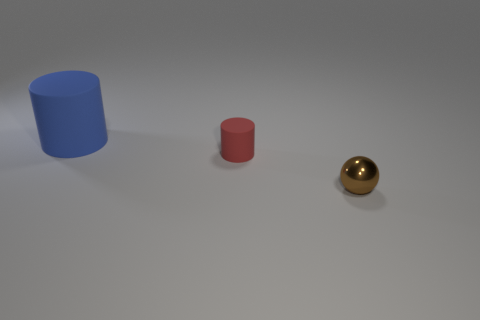Does the brown metallic object have the same size as the blue object?
Your response must be concise. No. What number of cylinders are made of the same material as the large thing?
Give a very brief answer. 1. The tiny rubber thing has what color?
Offer a terse response. Red. There is a tiny object behind the small brown ball; does it have the same shape as the blue rubber object?
Offer a very short reply. Yes. How many things are matte cylinders that are in front of the big object or red matte cylinders?
Ensure brevity in your answer.  1. Are there any large matte things that have the same shape as the metallic object?
Give a very brief answer. No. There is a red thing that is the same size as the brown sphere; what shape is it?
Your answer should be very brief. Cylinder. There is a tiny thing that is behind the object that is to the right of the tiny thing on the left side of the tiny brown shiny thing; what is its shape?
Offer a very short reply. Cylinder. There is a large rubber object; is it the same shape as the tiny object in front of the tiny rubber thing?
Give a very brief answer. No. How many large objects are brown things or matte cubes?
Offer a terse response. 0. 